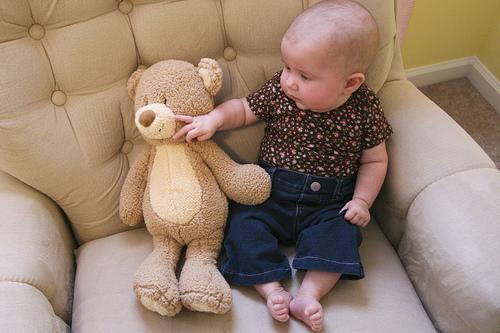How many chairs are there?
Give a very brief answer. 1. How many bears are there?
Give a very brief answer. 1. How many babies are there?
Give a very brief answer. 1. 